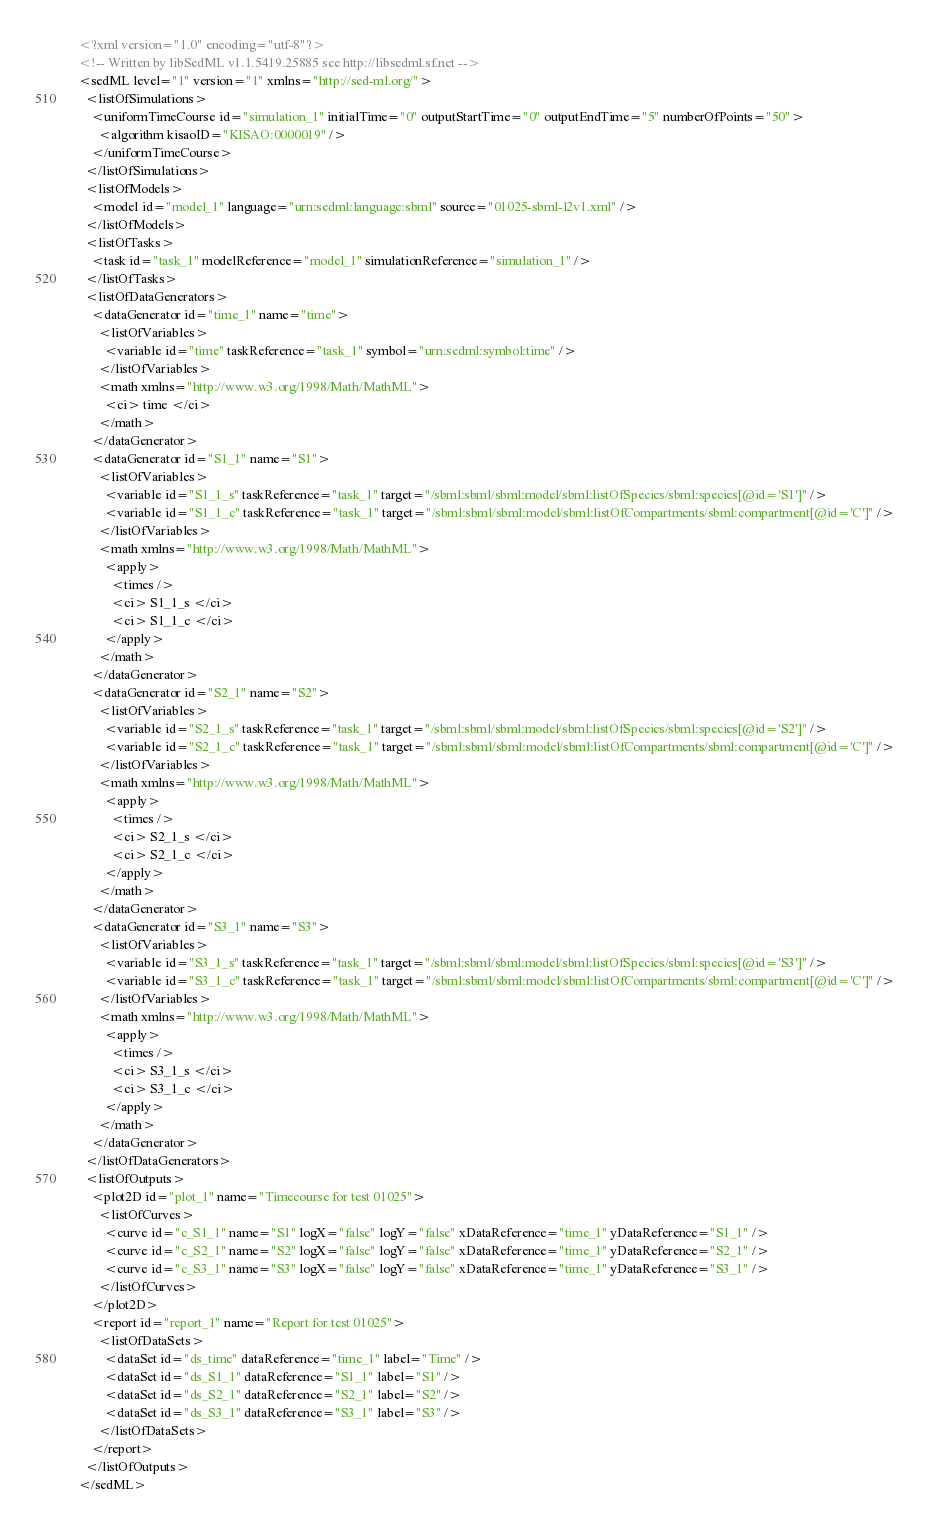<code> <loc_0><loc_0><loc_500><loc_500><_XML_><?xml version="1.0" encoding="utf-8"?>
<!-- Written by libSedML v1.1.5419.25885 see http://libsedml.sf.net -->
<sedML level="1" version="1" xmlns="http://sed-ml.org/">
  <listOfSimulations>
    <uniformTimeCourse id="simulation_1" initialTime="0" outputStartTime="0" outputEndTime="5" numberOfPoints="50">
      <algorithm kisaoID="KISAO:0000019" />
    </uniformTimeCourse>
  </listOfSimulations>
  <listOfModels>
    <model id="model_1" language="urn:sedml:language:sbml" source="01025-sbml-l2v1.xml" />
  </listOfModels>
  <listOfTasks>
    <task id="task_1" modelReference="model_1" simulationReference="simulation_1" />
  </listOfTasks>
  <listOfDataGenerators>
    <dataGenerator id="time_1" name="time">
      <listOfVariables>
        <variable id="time" taskReference="task_1" symbol="urn:sedml:symbol:time" />
      </listOfVariables>
      <math xmlns="http://www.w3.org/1998/Math/MathML">
        <ci> time </ci>
      </math>
    </dataGenerator>
    <dataGenerator id="S1_1" name="S1">
      <listOfVariables>
        <variable id="S1_1_s" taskReference="task_1" target="/sbml:sbml/sbml:model/sbml:listOfSpecies/sbml:species[@id='S1']" />
        <variable id="S1_1_c" taskReference="task_1" target="/sbml:sbml/sbml:model/sbml:listOfCompartments/sbml:compartment[@id='C']" />
      </listOfVariables>
      <math xmlns="http://www.w3.org/1998/Math/MathML">
        <apply>
          <times />
          <ci> S1_1_s </ci>
          <ci> S1_1_c </ci>
        </apply>
      </math>
    </dataGenerator>
    <dataGenerator id="S2_1" name="S2">
      <listOfVariables>
        <variable id="S2_1_s" taskReference="task_1" target="/sbml:sbml/sbml:model/sbml:listOfSpecies/sbml:species[@id='S2']" />
        <variable id="S2_1_c" taskReference="task_1" target="/sbml:sbml/sbml:model/sbml:listOfCompartments/sbml:compartment[@id='C']" />
      </listOfVariables>
      <math xmlns="http://www.w3.org/1998/Math/MathML">
        <apply>
          <times />
          <ci> S2_1_s </ci>
          <ci> S2_1_c </ci>
        </apply>
      </math>
    </dataGenerator>
    <dataGenerator id="S3_1" name="S3">
      <listOfVariables>
        <variable id="S3_1_s" taskReference="task_1" target="/sbml:sbml/sbml:model/sbml:listOfSpecies/sbml:species[@id='S3']" />
        <variable id="S3_1_c" taskReference="task_1" target="/sbml:sbml/sbml:model/sbml:listOfCompartments/sbml:compartment[@id='C']" />
      </listOfVariables>
      <math xmlns="http://www.w3.org/1998/Math/MathML">
        <apply>
          <times />
          <ci> S3_1_s </ci>
          <ci> S3_1_c </ci>
        </apply>
      </math>
    </dataGenerator>
  </listOfDataGenerators>
  <listOfOutputs>
    <plot2D id="plot_1" name="Timecourse for test 01025">
      <listOfCurves>
        <curve id="c_S1_1" name="S1" logX="false" logY="false" xDataReference="time_1" yDataReference="S1_1" />
        <curve id="c_S2_1" name="S2" logX="false" logY="false" xDataReference="time_1" yDataReference="S2_1" />
        <curve id="c_S3_1" name="S3" logX="false" logY="false" xDataReference="time_1" yDataReference="S3_1" />
      </listOfCurves>
    </plot2D>
    <report id="report_1" name="Report for test 01025">
      <listOfDataSets>
        <dataSet id="ds_time" dataReference="time_1" label="Time" />
        <dataSet id="ds_S1_1" dataReference="S1_1" label="S1" />
        <dataSet id="ds_S2_1" dataReference="S2_1" label="S2" />
        <dataSet id="ds_S3_1" dataReference="S3_1" label="S3" />
      </listOfDataSets>
    </report>
  </listOfOutputs>
</sedML></code> 